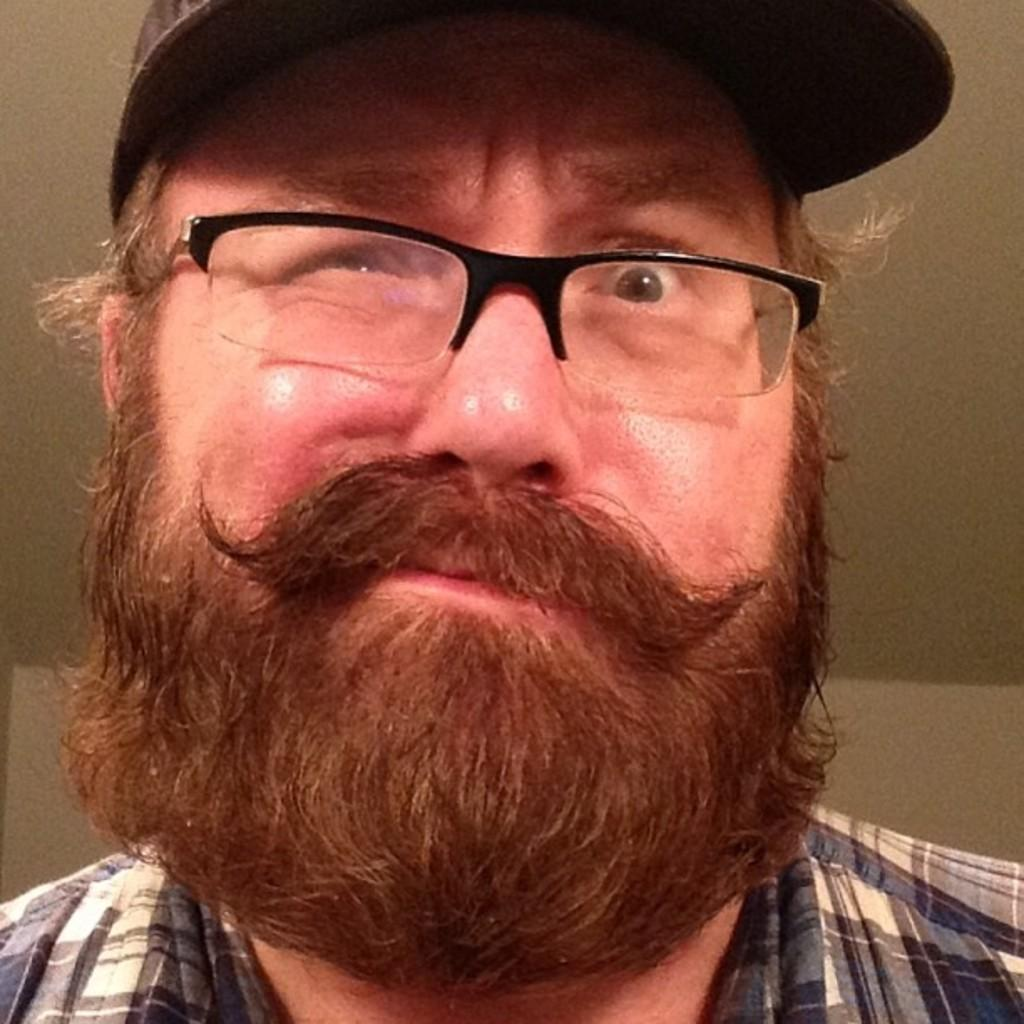Who is present in the image? There is a man in the image. What accessories is the man wearing? The man is wearing glasses and a cap. What can be seen in the background of the image? There is a ceiling and a wall in the background of the image. What type of pipe is the man holding in the image? There is no pipe present in the image; the man is only wearing glasses and a cap. 